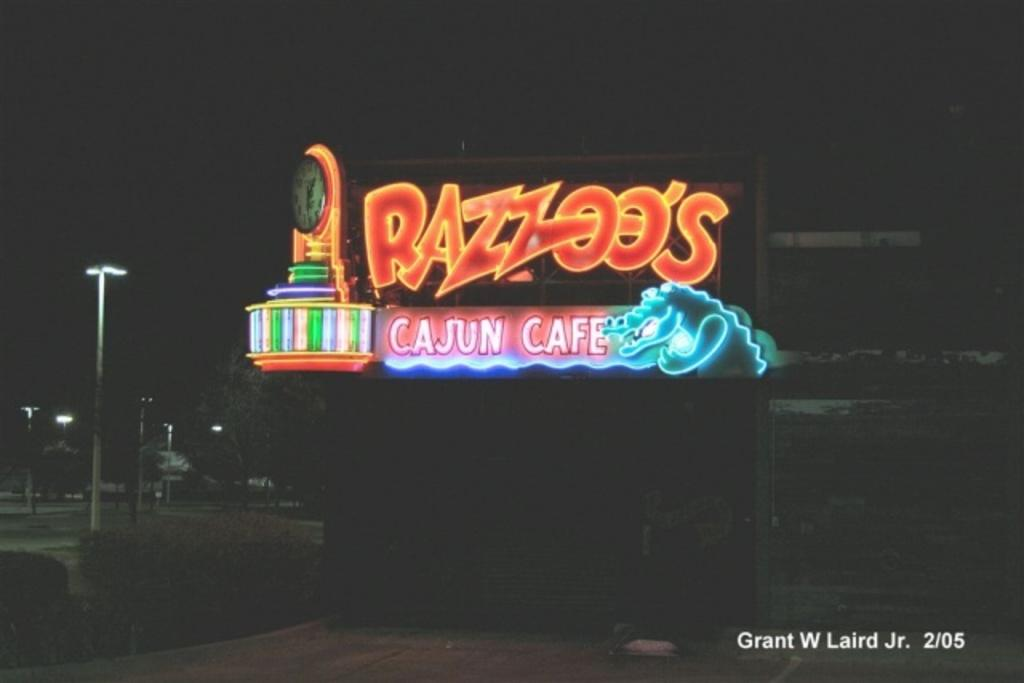Provide a one-sentence caption for the provided image. Neon lights sign brightly in the night sky above Razzoo's. 